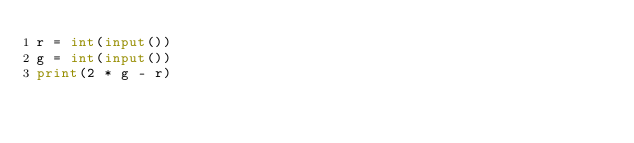Convert code to text. <code><loc_0><loc_0><loc_500><loc_500><_Python_>r = int(input())
g = int(input())
print(2 * g - r)</code> 